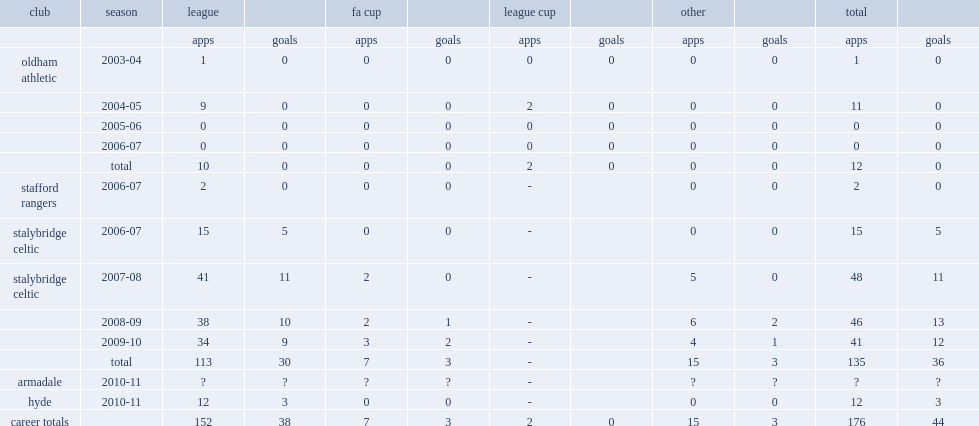How many goals did matty barlow score for stalybrige in three seasons. 36.0. 